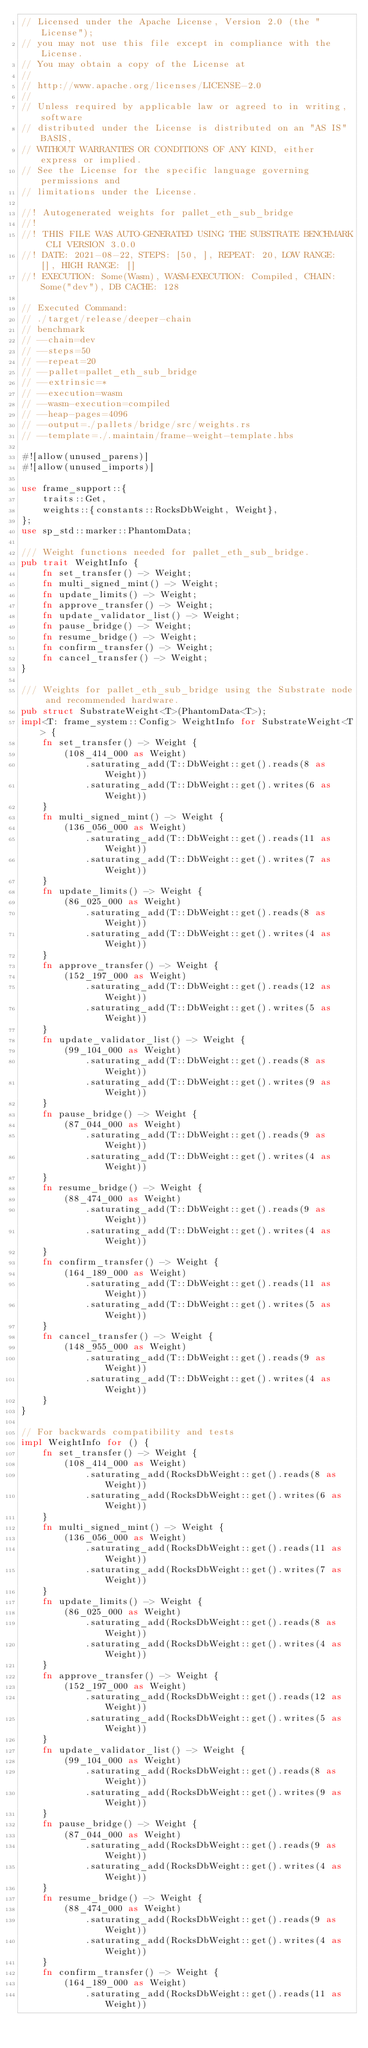Convert code to text. <code><loc_0><loc_0><loc_500><loc_500><_Rust_>// Licensed under the Apache License, Version 2.0 (the "License");
// you may not use this file except in compliance with the License.
// You may obtain a copy of the License at
//
// http://www.apache.org/licenses/LICENSE-2.0
//
// Unless required by applicable law or agreed to in writing, software
// distributed under the License is distributed on an "AS IS" BASIS,
// WITHOUT WARRANTIES OR CONDITIONS OF ANY KIND, either express or implied.
// See the License for the specific language governing permissions and
// limitations under the License.

//! Autogenerated weights for pallet_eth_sub_bridge
//!
//! THIS FILE WAS AUTO-GENERATED USING THE SUBSTRATE BENCHMARK CLI VERSION 3.0.0
//! DATE: 2021-08-22, STEPS: [50, ], REPEAT: 20, LOW RANGE: [], HIGH RANGE: []
//! EXECUTION: Some(Wasm), WASM-EXECUTION: Compiled, CHAIN: Some("dev"), DB CACHE: 128

// Executed Command:
// ./target/release/deeper-chain
// benchmark
// --chain=dev
// --steps=50
// --repeat=20
// --pallet=pallet_eth_sub_bridge
// --extrinsic=*
// --execution=wasm
// --wasm-execution=compiled
// --heap-pages=4096
// --output=./pallets/bridge/src/weights.rs
// --template=./.maintain/frame-weight-template.hbs

#![allow(unused_parens)]
#![allow(unused_imports)]

use frame_support::{
    traits::Get,
    weights::{constants::RocksDbWeight, Weight},
};
use sp_std::marker::PhantomData;

/// Weight functions needed for pallet_eth_sub_bridge.
pub trait WeightInfo {
    fn set_transfer() -> Weight;
    fn multi_signed_mint() -> Weight;
    fn update_limits() -> Weight;
    fn approve_transfer() -> Weight;
    fn update_validator_list() -> Weight;
    fn pause_bridge() -> Weight;
    fn resume_bridge() -> Weight;
    fn confirm_transfer() -> Weight;
    fn cancel_transfer() -> Weight;
}

/// Weights for pallet_eth_sub_bridge using the Substrate node and recommended hardware.
pub struct SubstrateWeight<T>(PhantomData<T>);
impl<T: frame_system::Config> WeightInfo for SubstrateWeight<T> {
    fn set_transfer() -> Weight {
        (108_414_000 as Weight)
            .saturating_add(T::DbWeight::get().reads(8 as Weight))
            .saturating_add(T::DbWeight::get().writes(6 as Weight))
    }
    fn multi_signed_mint() -> Weight {
        (136_056_000 as Weight)
            .saturating_add(T::DbWeight::get().reads(11 as Weight))
            .saturating_add(T::DbWeight::get().writes(7 as Weight))
    }
    fn update_limits() -> Weight {
        (86_025_000 as Weight)
            .saturating_add(T::DbWeight::get().reads(8 as Weight))
            .saturating_add(T::DbWeight::get().writes(4 as Weight))
    }
    fn approve_transfer() -> Weight {
        (152_197_000 as Weight)
            .saturating_add(T::DbWeight::get().reads(12 as Weight))
            .saturating_add(T::DbWeight::get().writes(5 as Weight))
    }
    fn update_validator_list() -> Weight {
        (99_104_000 as Weight)
            .saturating_add(T::DbWeight::get().reads(8 as Weight))
            .saturating_add(T::DbWeight::get().writes(9 as Weight))
    }
    fn pause_bridge() -> Weight {
        (87_044_000 as Weight)
            .saturating_add(T::DbWeight::get().reads(9 as Weight))
            .saturating_add(T::DbWeight::get().writes(4 as Weight))
    }
    fn resume_bridge() -> Weight {
        (88_474_000 as Weight)
            .saturating_add(T::DbWeight::get().reads(9 as Weight))
            .saturating_add(T::DbWeight::get().writes(4 as Weight))
    }
    fn confirm_transfer() -> Weight {
        (164_189_000 as Weight)
            .saturating_add(T::DbWeight::get().reads(11 as Weight))
            .saturating_add(T::DbWeight::get().writes(5 as Weight))
    }
    fn cancel_transfer() -> Weight {
        (148_955_000 as Weight)
            .saturating_add(T::DbWeight::get().reads(9 as Weight))
            .saturating_add(T::DbWeight::get().writes(4 as Weight))
    }
}

// For backwards compatibility and tests
impl WeightInfo for () {
    fn set_transfer() -> Weight {
        (108_414_000 as Weight)
            .saturating_add(RocksDbWeight::get().reads(8 as Weight))
            .saturating_add(RocksDbWeight::get().writes(6 as Weight))
    }
    fn multi_signed_mint() -> Weight {
        (136_056_000 as Weight)
            .saturating_add(RocksDbWeight::get().reads(11 as Weight))
            .saturating_add(RocksDbWeight::get().writes(7 as Weight))
    }
    fn update_limits() -> Weight {
        (86_025_000 as Weight)
            .saturating_add(RocksDbWeight::get().reads(8 as Weight))
            .saturating_add(RocksDbWeight::get().writes(4 as Weight))
    }
    fn approve_transfer() -> Weight {
        (152_197_000 as Weight)
            .saturating_add(RocksDbWeight::get().reads(12 as Weight))
            .saturating_add(RocksDbWeight::get().writes(5 as Weight))
    }
    fn update_validator_list() -> Weight {
        (99_104_000 as Weight)
            .saturating_add(RocksDbWeight::get().reads(8 as Weight))
            .saturating_add(RocksDbWeight::get().writes(9 as Weight))
    }
    fn pause_bridge() -> Weight {
        (87_044_000 as Weight)
            .saturating_add(RocksDbWeight::get().reads(9 as Weight))
            .saturating_add(RocksDbWeight::get().writes(4 as Weight))
    }
    fn resume_bridge() -> Weight {
        (88_474_000 as Weight)
            .saturating_add(RocksDbWeight::get().reads(9 as Weight))
            .saturating_add(RocksDbWeight::get().writes(4 as Weight))
    }
    fn confirm_transfer() -> Weight {
        (164_189_000 as Weight)
            .saturating_add(RocksDbWeight::get().reads(11 as Weight))</code> 